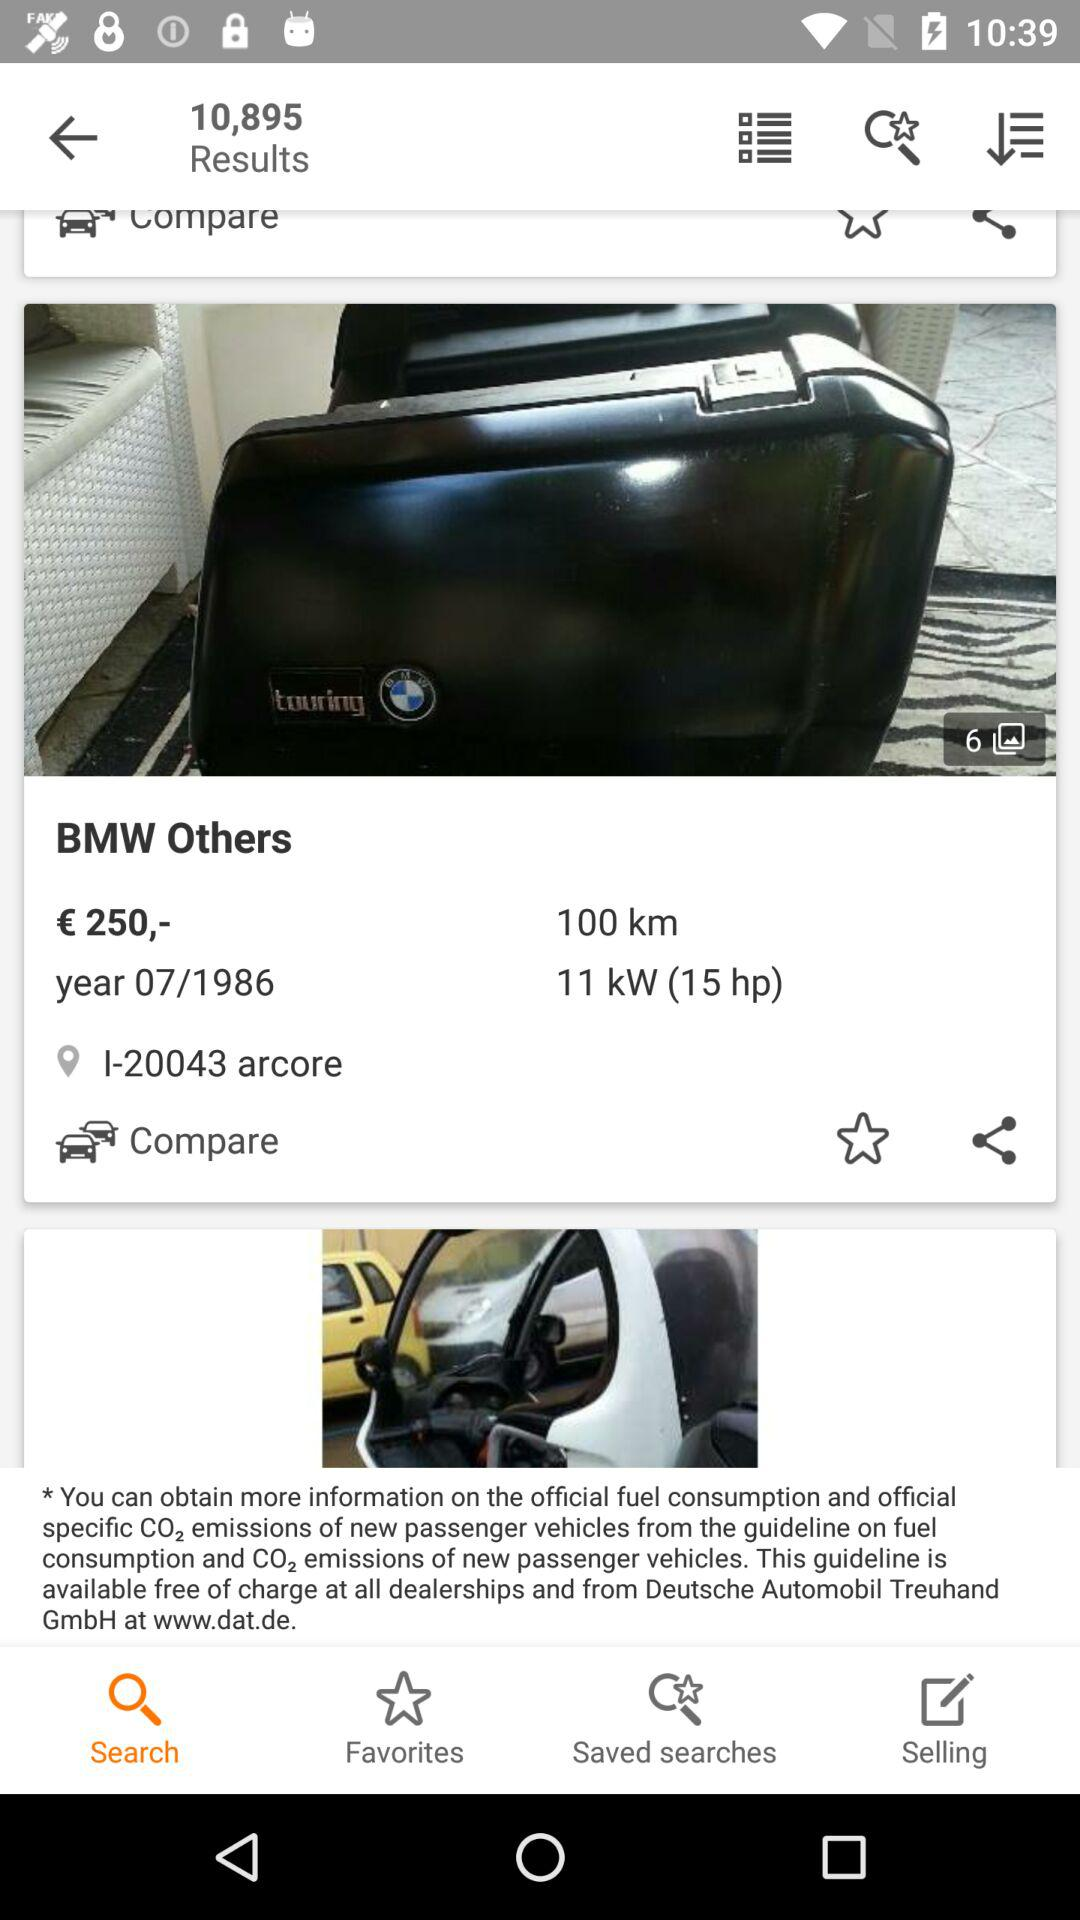Which tab is selected? The selected tab is "Search". 